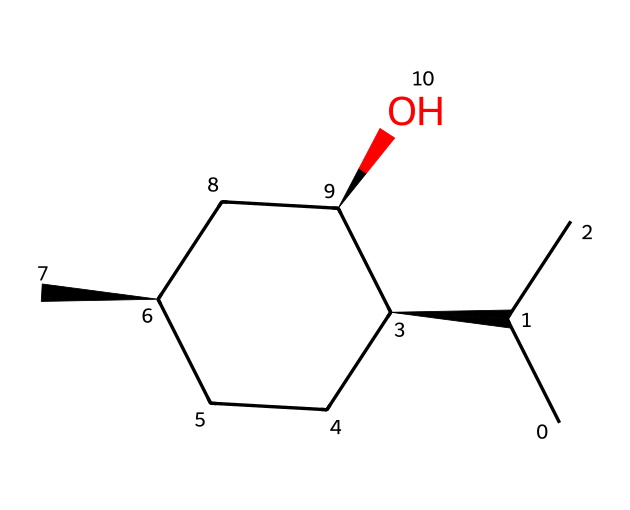What is the molecular formula of menthol? To derive the molecular formula, count the number of carbon (C), hydrogen (H), and oxygen (O) atoms in the structure. There are 10 carbon atoms, 20 hydrogen atoms, and 1 oxygen atom. Therefore, the formula is C10H20O.
Answer: C10H20O How many chiral centers are in menthol? By analyzing the molecular structure, we can identify the chiral centers, which are typically carbon atoms bonded to four different substituents. In this structure, there are three chiral centers, marked by the stereochemistry symbols (@).
Answer: 3 What type of chemical compound is menthol? Menthol is classified as a terpene, a type of organic compound characterized by a specific carbon structure typically containing multiple isoprene units. This is inferred from its cyclic structure and composition.
Answer: terpene Which atom in menthol is responsible for its solubility in organic solvents? The presence of the hydroxyl group (-OH) in the structure increases polarity, making menthol soluble in organic solvents due to its ability to form hydrogen bonds; thus, this feature is critical for solubility.
Answer: hydroxyl group What is the total number of rings present in the menthol structure? By examining the structure, we observe there is one cycloalkane ring present, which is a distinct feature of menthol. Count the circular structure to confirm its presence.
Answer: 1 Does menthol contain any double bonds? Analyzing the chemical structure shows all carbon-carbon connections are single bonds, indicating that menthol has no double bonds.
Answer: no 